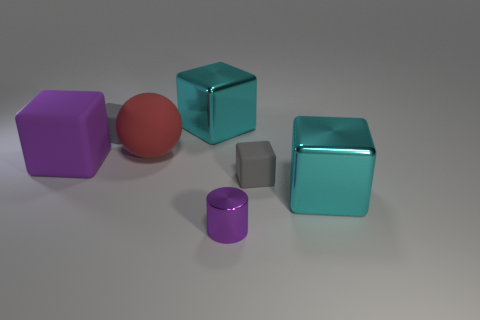There is a sphere that is the same size as the purple block; what material is it? The sphere appears to have a similar matte finish and light reflecting properties as the purple block, suggesting that they could both be made of a non-glossy painted material, possibly a type of dense plastic or treated wood. 